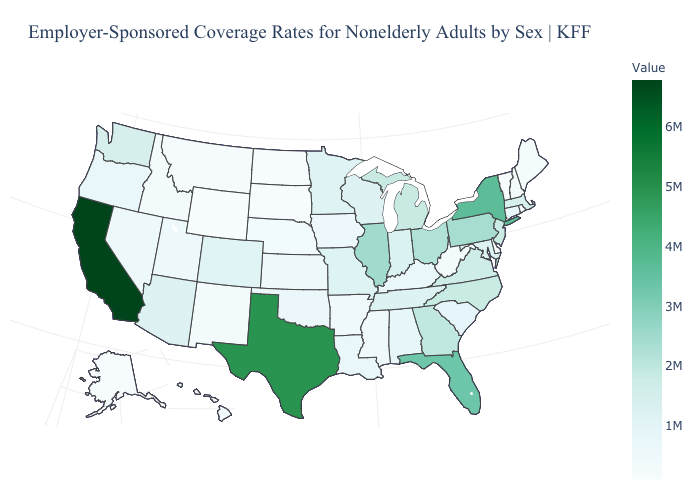Which states have the lowest value in the USA?
Answer briefly. Wyoming. Which states have the highest value in the USA?
Be succinct. California. Among the states that border Utah , does Wyoming have the lowest value?
Write a very short answer. Yes. Does California have the highest value in the USA?
Give a very brief answer. Yes. Does California have the highest value in the West?
Answer briefly. Yes. Among the states that border Tennessee , which have the highest value?
Give a very brief answer. Georgia. Which states have the lowest value in the USA?
Keep it brief. Wyoming. 